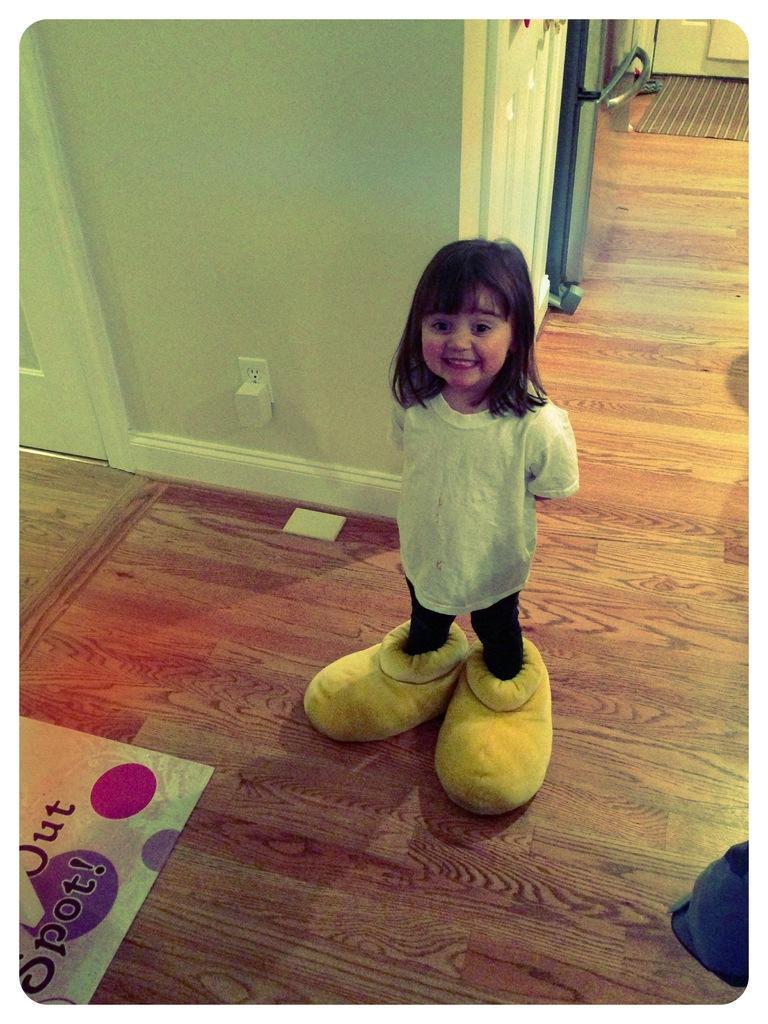Can you describe this image briefly? Here we can see a girl,kept her two legs in the shoes. In the background there is an adapter to a socket on the wall,door,a metal item and there is a mat,paper and an object on the floor. 